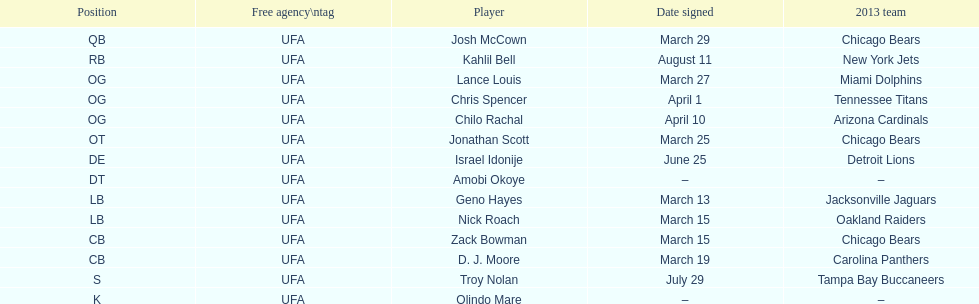Last name is also a first name beginning with "n" Troy Nolan. Could you parse the entire table? {'header': ['Position', 'Free agency\\ntag', 'Player', 'Date signed', '2013 team'], 'rows': [['QB', 'UFA', 'Josh McCown', 'March 29', 'Chicago Bears'], ['RB', 'UFA', 'Kahlil Bell', 'August 11', 'New York Jets'], ['OG', 'UFA', 'Lance Louis', 'March 27', 'Miami Dolphins'], ['OG', 'UFA', 'Chris Spencer', 'April 1', 'Tennessee Titans'], ['OG', 'UFA', 'Chilo Rachal', 'April 10', 'Arizona Cardinals'], ['OT', 'UFA', 'Jonathan Scott', 'March 25', 'Chicago Bears'], ['DE', 'UFA', 'Israel Idonije', 'June 25', 'Detroit Lions'], ['DT', 'UFA', 'Amobi Okoye', '–', '–'], ['LB', 'UFA', 'Geno Hayes', 'March 13', 'Jacksonville Jaguars'], ['LB', 'UFA', 'Nick Roach', 'March 15', 'Oakland Raiders'], ['CB', 'UFA', 'Zack Bowman', 'March 15', 'Chicago Bears'], ['CB', 'UFA', 'D. J. Moore', 'March 19', 'Carolina Panthers'], ['S', 'UFA', 'Troy Nolan', 'July 29', 'Tampa Bay Buccaneers'], ['K', 'UFA', 'Olindo Mare', '–', '–']]} 